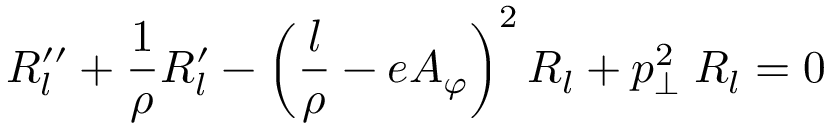Convert formula to latex. <formula><loc_0><loc_0><loc_500><loc_500>R _ { l } ^ { \prime \prime } + { \frac { 1 } { \rho } } R _ { l } ^ { \prime } - \left ( { \frac { l } { \rho } } - e A _ { \varphi } \right ) ^ { 2 } R _ { l } + p _ { \perp } ^ { 2 } \, R _ { l } = 0</formula> 